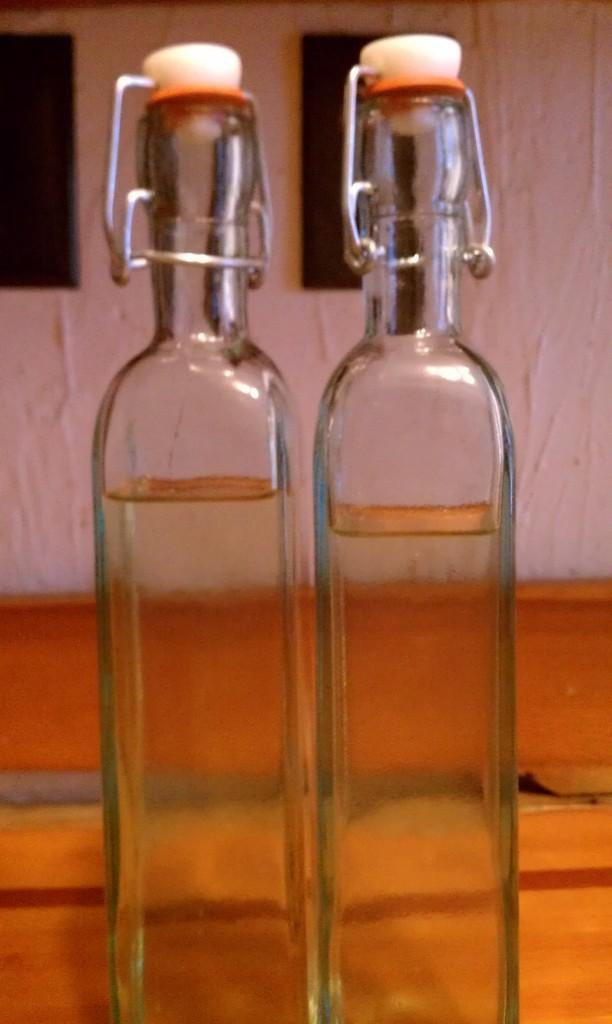How many bottles are visible in the image? There are two bottles in the image. What feature do the bottles have in common? The bottles have caps. What is inside the bottles? There is liquid in the bottles. On what surface are the bottles placed? The bottles are placed on a wooden table. What type of whip can be seen cracking in the image? There is no whip present in the image. How many stars are visible in the image? There are no stars visible in the image. 